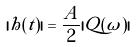Convert formula to latex. <formula><loc_0><loc_0><loc_500><loc_500>| h ( t ) | = \frac { A } { 2 } | Q ( \omega ) |</formula> 